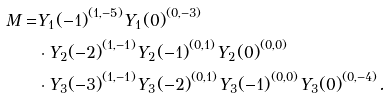Convert formula to latex. <formula><loc_0><loc_0><loc_500><loc_500>M = & { Y _ { 1 } ( - 1 ) } ^ { ( 1 , - 5 ) } { Y _ { 1 } ( 0 ) } ^ { ( 0 , - 3 ) } \\ & \cdot { Y _ { 2 } ( - 2 ) } ^ { ( 1 , - 1 ) } { Y _ { 2 } ( - 1 ) } ^ { ( 0 , 1 ) } { Y _ { 2 } ( 0 ) } ^ { ( 0 , 0 ) } \\ & \cdot { Y _ { 3 } ( - 3 ) } ^ { ( 1 , - 1 ) } { Y _ { 3 } ( - 2 ) } ^ { ( 0 , 1 ) } { Y _ { 3 } ( - 1 ) } ^ { ( 0 , 0 ) } { Y _ { 3 } ( 0 ) } ^ { ( 0 , - 4 ) } .</formula> 